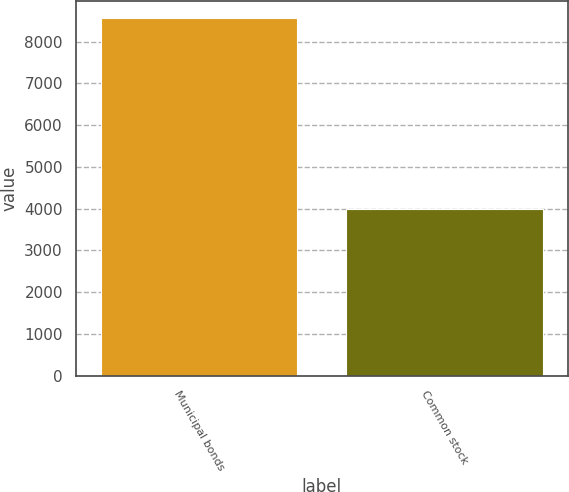Convert chart. <chart><loc_0><loc_0><loc_500><loc_500><bar_chart><fcel>Municipal bonds<fcel>Common stock<nl><fcel>8556<fcel>3998<nl></chart> 